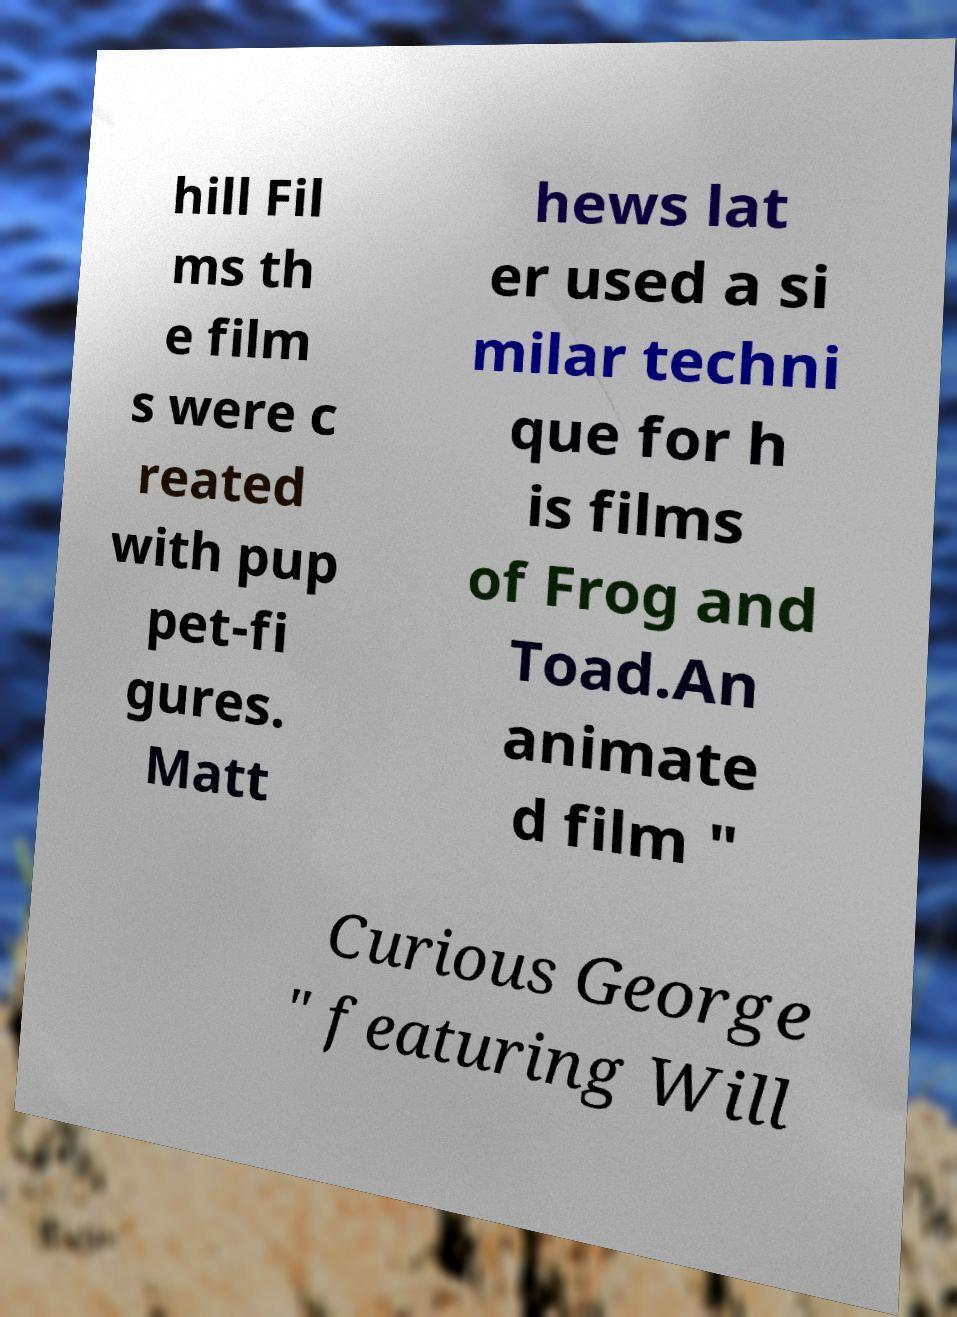There's text embedded in this image that I need extracted. Can you transcribe it verbatim? hill Fil ms th e film s were c reated with pup pet-fi gures. Matt hews lat er used a si milar techni que for h is films of Frog and Toad.An animate d film " Curious George " featuring Will 